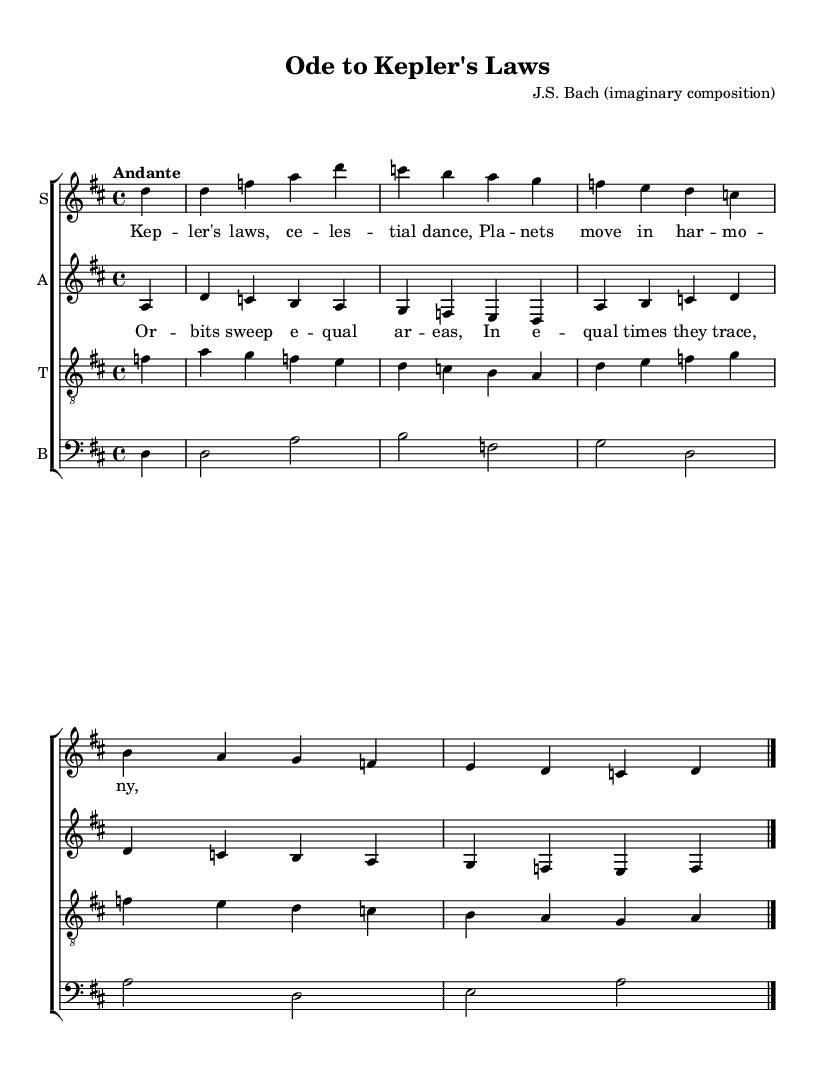What is the key signature of this music? The key signature is indicated by the sharp symbols at the beginning of the staff. Here, there is two sharps, which indicates that the key is D major.
Answer: D major What is the time signature of the music? The time signature is typically specified at the beginning of the score, shown as a fraction. In this case, it is 4/4, meaning there are four beats in each measure.
Answer: 4/4 What is the tempo marking for the piece? The tempo marking is written above the score to indicate how fast the piece should be played. Here, it reads "Andante", suggesting a moderate pace.
Answer: Andante How many distinct voice parts are in the choral composition? To determine the number of voice parts, we look at the score sections. In this sheet music, there are parts for soprano, alto, tenor, and bass, totaling four distinct voices.
Answer: Four Which composer is attributed to this composition? The composer's name is usually included in the header of the score. Here, it states “J.S. Bach (imaginary composition)”, indicating it is attributed to the famous Baroque composer J.S. Bach, albeit as a fictional piece.
Answer: J.S. Bach (imaginary composition) What do the lyrics of the soprano voice celebrate? To find out what the lyrics celebrate, examine the text provided with the soprano voice part. The lyrics mention "Kepler's laws," indicating a celebration of scientific discoveries related to celestial movement.
Answer: Kepler's laws What are the dynamics indicated for the piece? Dynamics are often indicated in the music through specific markings on the score. In this particular sheet, there are no dynamics specified, suggesting a performance with moderate dynamics, but more information could be inferred by performance practices of the Baroque style.
Answer: None indicated 